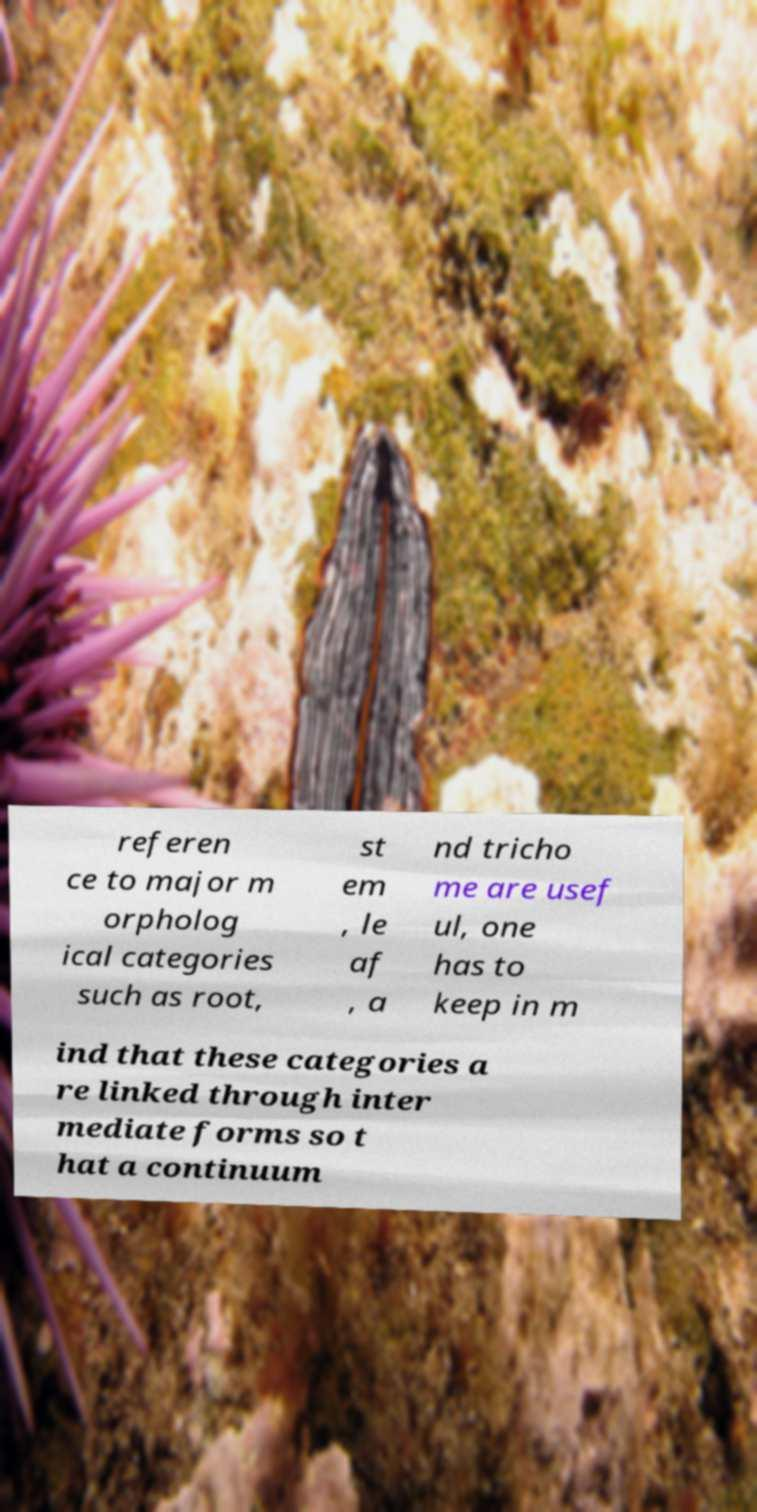Can you accurately transcribe the text from the provided image for me? referen ce to major m orpholog ical categories such as root, st em , le af , a nd tricho me are usef ul, one has to keep in m ind that these categories a re linked through inter mediate forms so t hat a continuum 